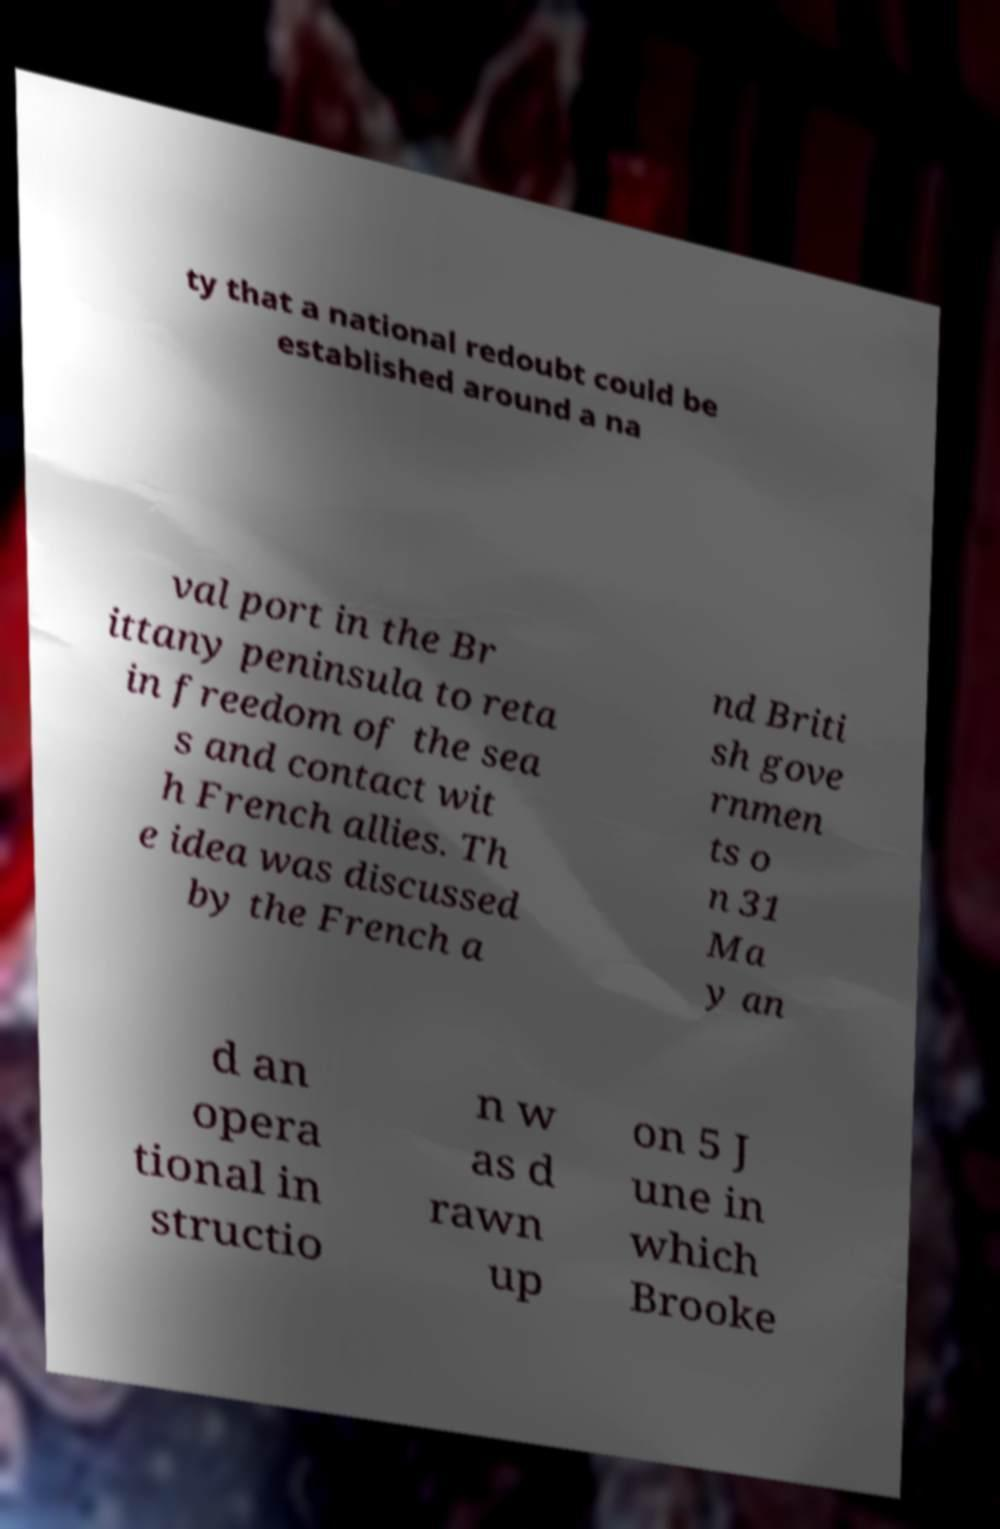There's text embedded in this image that I need extracted. Can you transcribe it verbatim? ty that a national redoubt could be established around a na val port in the Br ittany peninsula to reta in freedom of the sea s and contact wit h French allies. Th e idea was discussed by the French a nd Briti sh gove rnmen ts o n 31 Ma y an d an opera tional in structio n w as d rawn up on 5 J une in which Brooke 